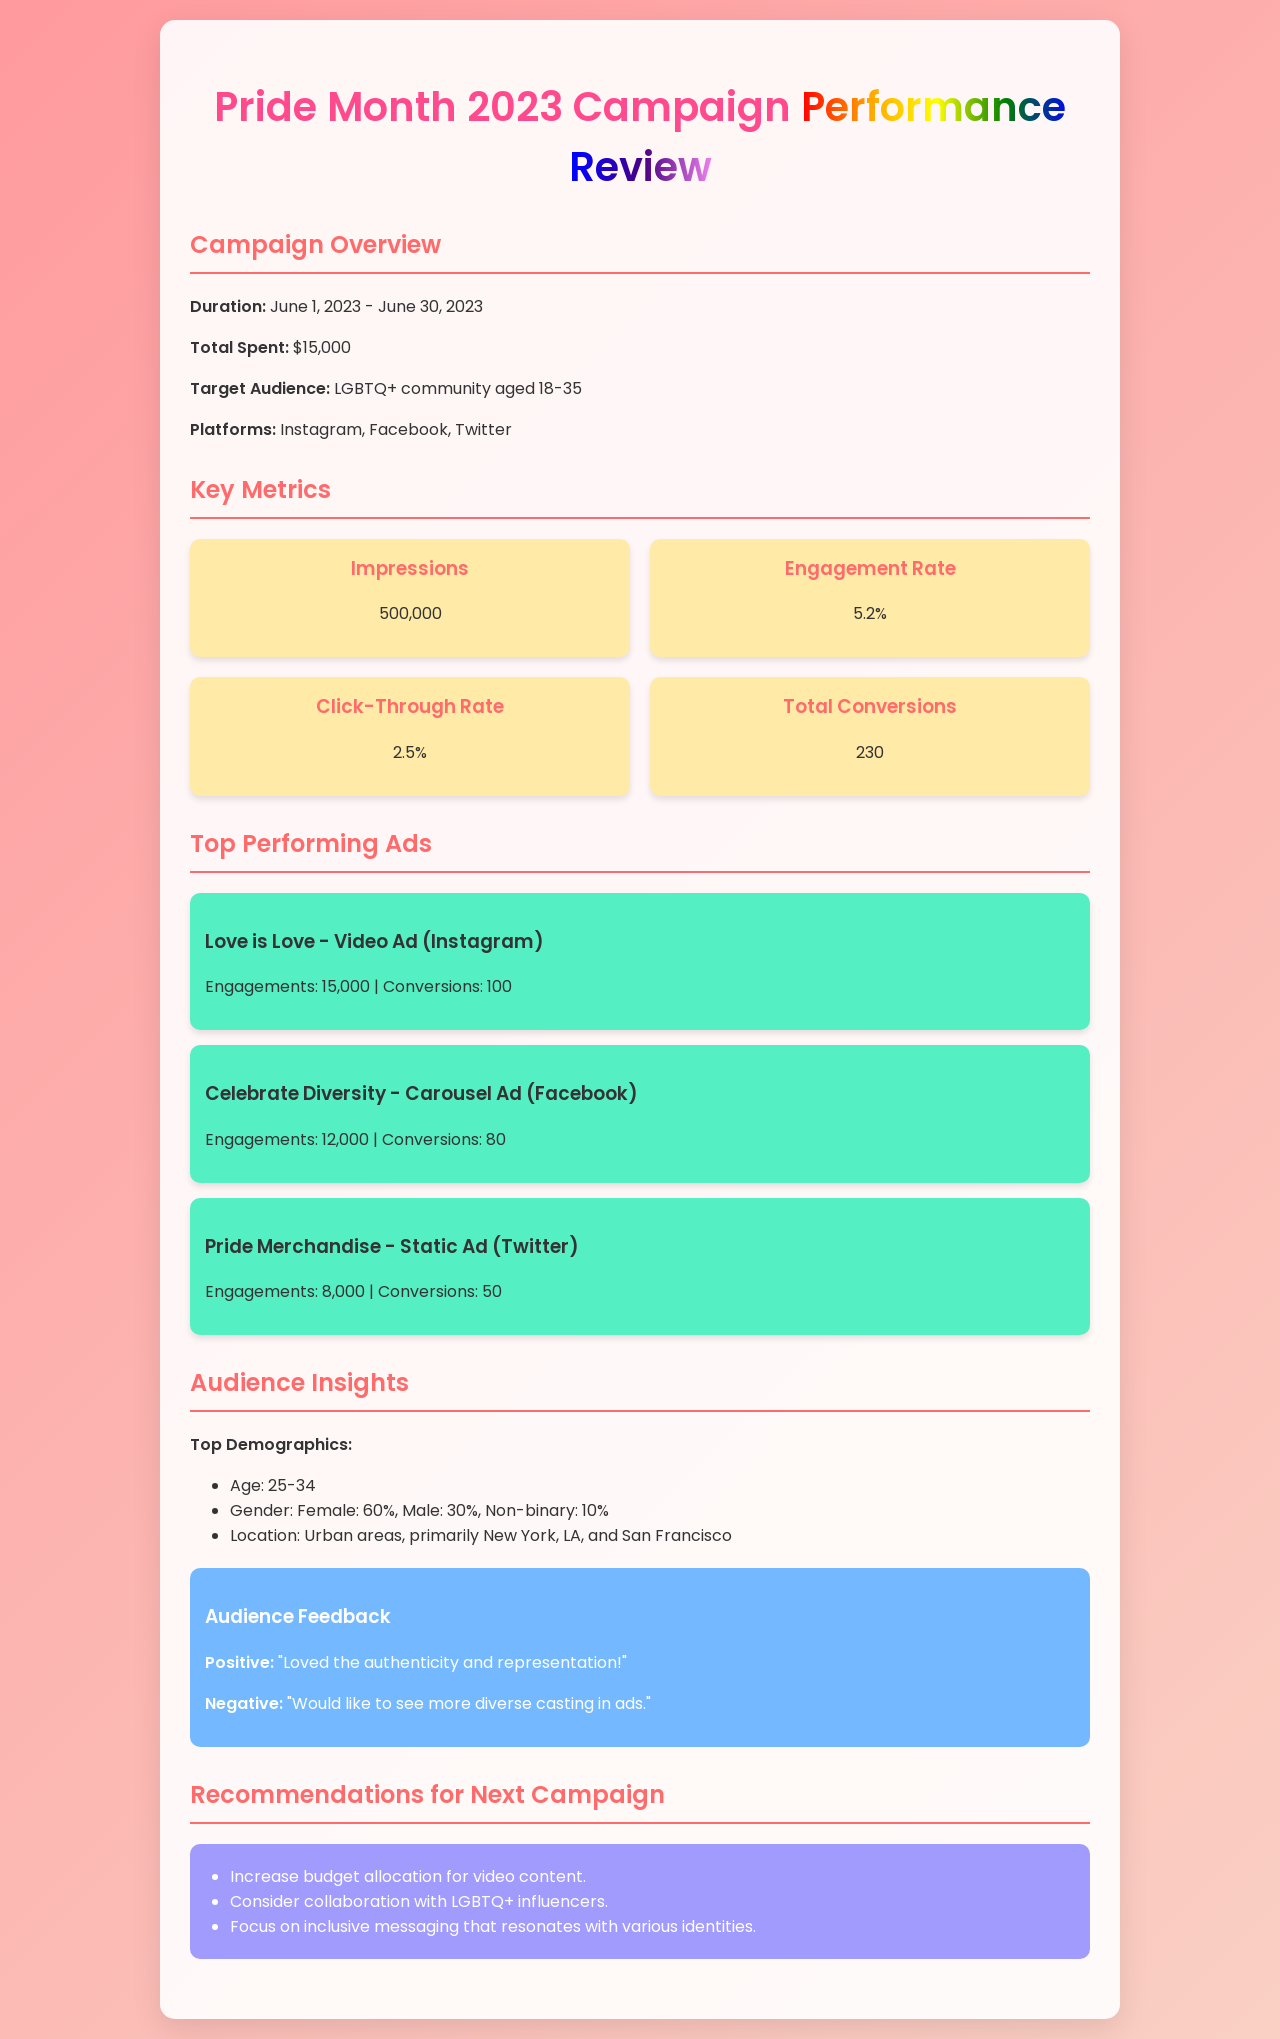what was the campaign duration? The campaign duration is specified in the document as being from June 1, 2023, to June 30, 2023.
Answer: June 1, 2023 - June 30, 2023 how much was the total spent on the campaign? The document indicates the total amount spent on the campaign.
Answer: $15,000 what was the engagement rate achieved? The document provides the engagement rate as a key metric for the campaign's performance.
Answer: 5.2% how many total conversions were recorded? Total conversions are listed in the metrics section, summarizing the campaign's performance.
Answer: 230 which platform had the highest engagements for an ad? The document lists the three top-performing ads with their engagements, which helps identify the platform with the highest engagement.
Answer: Instagram what is the top demographic age range? The document specifies the top demographic age range in the audience insights section.
Answer: 25-34 what was a negative piece of audience feedback? The document includes audience feedback, which can include both positive and negative comments.
Answer: "Would like to see more diverse casting in ads." what is one recommendation for the next campaign? The recommendations section lists several suggestions for the next campaign based on insights from the current campaign.
Answer: Increase budget allocation for video content which ad had the highest conversions? The document provides a list of top ads along with their conversions, allowing us to identify the ad with the highest number.
Answer: Love is Love - Video Ad (Instagram) 